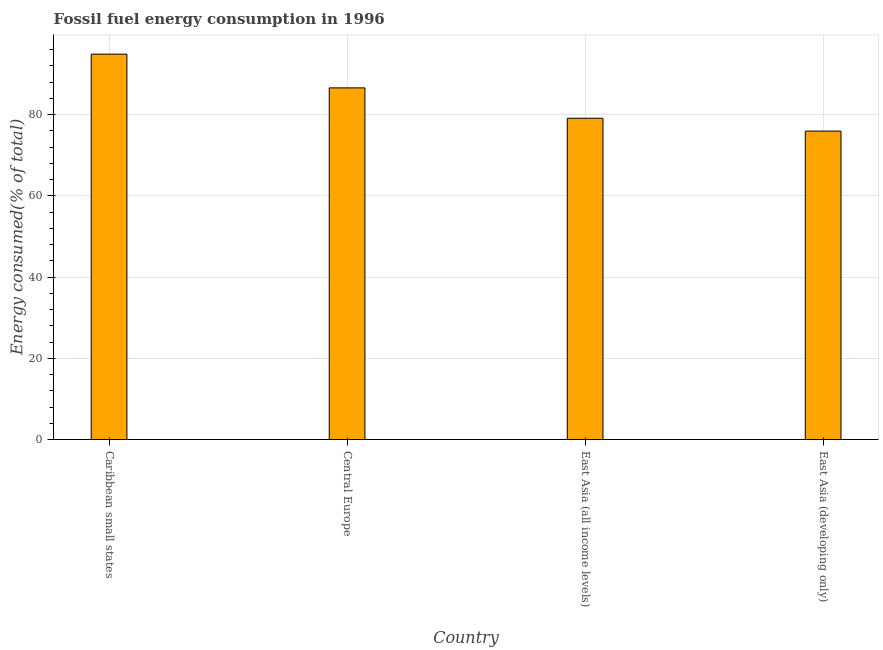Does the graph contain any zero values?
Make the answer very short. No. Does the graph contain grids?
Provide a succinct answer. Yes. What is the title of the graph?
Give a very brief answer. Fossil fuel energy consumption in 1996. What is the label or title of the X-axis?
Offer a very short reply. Country. What is the label or title of the Y-axis?
Give a very brief answer. Energy consumed(% of total). What is the fossil fuel energy consumption in East Asia (all income levels)?
Your answer should be compact. 79.13. Across all countries, what is the maximum fossil fuel energy consumption?
Your response must be concise. 94.92. Across all countries, what is the minimum fossil fuel energy consumption?
Give a very brief answer. 75.97. In which country was the fossil fuel energy consumption maximum?
Provide a short and direct response. Caribbean small states. In which country was the fossil fuel energy consumption minimum?
Offer a terse response. East Asia (developing only). What is the sum of the fossil fuel energy consumption?
Provide a short and direct response. 336.62. What is the difference between the fossil fuel energy consumption in Caribbean small states and East Asia (developing only)?
Ensure brevity in your answer.  18.95. What is the average fossil fuel energy consumption per country?
Ensure brevity in your answer.  84.16. What is the median fossil fuel energy consumption?
Your response must be concise. 82.87. What is the ratio of the fossil fuel energy consumption in Caribbean small states to that in East Asia (developing only)?
Offer a terse response. 1.25. Is the fossil fuel energy consumption in Central Europe less than that in East Asia (developing only)?
Make the answer very short. No. Is the difference between the fossil fuel energy consumption in Caribbean small states and East Asia (all income levels) greater than the difference between any two countries?
Provide a short and direct response. No. What is the difference between the highest and the second highest fossil fuel energy consumption?
Provide a short and direct response. 8.31. What is the difference between the highest and the lowest fossil fuel energy consumption?
Give a very brief answer. 18.95. In how many countries, is the fossil fuel energy consumption greater than the average fossil fuel energy consumption taken over all countries?
Offer a terse response. 2. How many bars are there?
Give a very brief answer. 4. Are the values on the major ticks of Y-axis written in scientific E-notation?
Your answer should be compact. No. What is the Energy consumed(% of total) of Caribbean small states?
Offer a very short reply. 94.92. What is the Energy consumed(% of total) in Central Europe?
Provide a short and direct response. 86.61. What is the Energy consumed(% of total) in East Asia (all income levels)?
Offer a very short reply. 79.13. What is the Energy consumed(% of total) of East Asia (developing only)?
Provide a short and direct response. 75.97. What is the difference between the Energy consumed(% of total) in Caribbean small states and Central Europe?
Give a very brief answer. 8.31. What is the difference between the Energy consumed(% of total) in Caribbean small states and East Asia (all income levels)?
Your answer should be very brief. 15.79. What is the difference between the Energy consumed(% of total) in Caribbean small states and East Asia (developing only)?
Keep it short and to the point. 18.95. What is the difference between the Energy consumed(% of total) in Central Europe and East Asia (all income levels)?
Offer a very short reply. 7.48. What is the difference between the Energy consumed(% of total) in Central Europe and East Asia (developing only)?
Provide a short and direct response. 10.64. What is the difference between the Energy consumed(% of total) in East Asia (all income levels) and East Asia (developing only)?
Ensure brevity in your answer.  3.16. What is the ratio of the Energy consumed(% of total) in Caribbean small states to that in Central Europe?
Make the answer very short. 1.1. What is the ratio of the Energy consumed(% of total) in Caribbean small states to that in East Asia (developing only)?
Ensure brevity in your answer.  1.25. What is the ratio of the Energy consumed(% of total) in Central Europe to that in East Asia (all income levels)?
Your answer should be compact. 1.09. What is the ratio of the Energy consumed(% of total) in Central Europe to that in East Asia (developing only)?
Your answer should be compact. 1.14. What is the ratio of the Energy consumed(% of total) in East Asia (all income levels) to that in East Asia (developing only)?
Your answer should be compact. 1.04. 